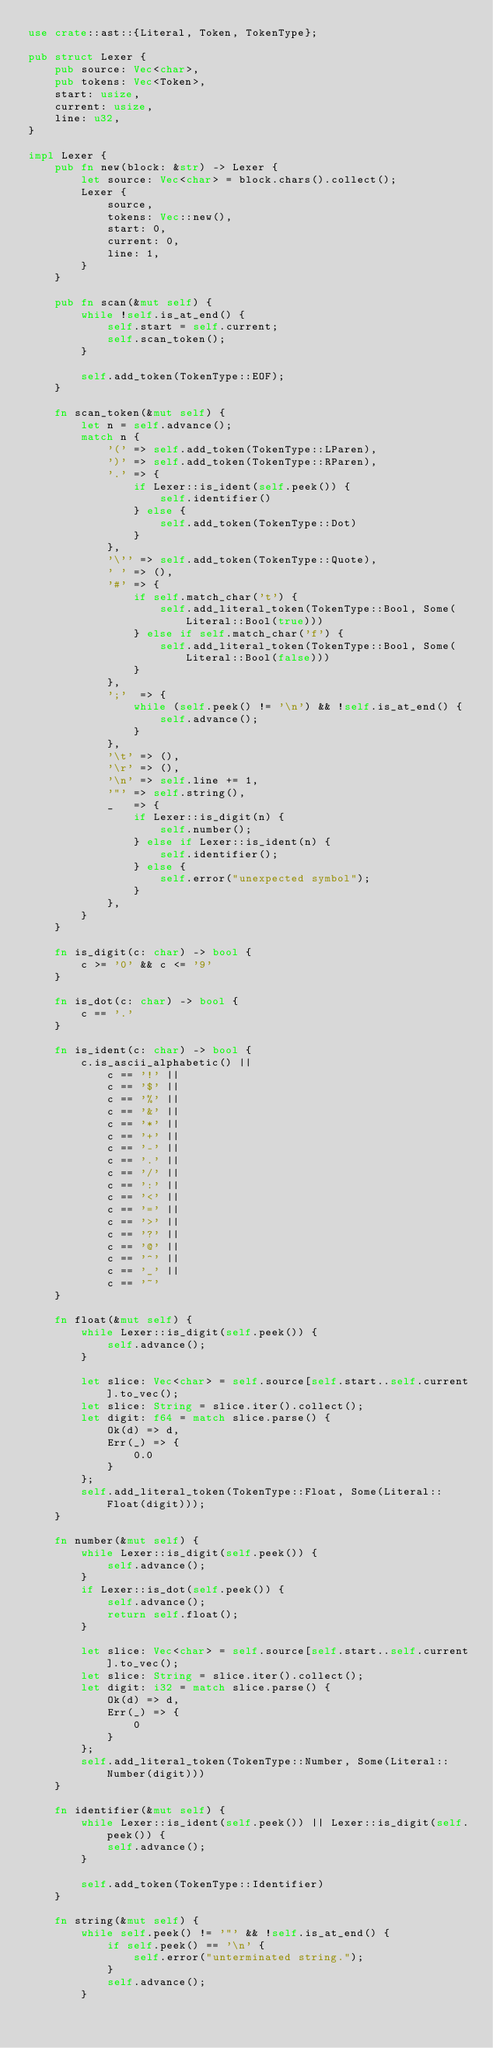Convert code to text. <code><loc_0><loc_0><loc_500><loc_500><_Rust_>use crate::ast::{Literal, Token, TokenType};

pub struct Lexer {
    pub source: Vec<char>,
    pub tokens: Vec<Token>,
    start: usize,
    current: usize,
    line: u32,
}

impl Lexer {
    pub fn new(block: &str) -> Lexer {
        let source: Vec<char> = block.chars().collect();
        Lexer {
            source,
            tokens: Vec::new(),
            start: 0,
            current: 0,
            line: 1,
        }
    }

    pub fn scan(&mut self) {
        while !self.is_at_end() {
            self.start = self.current;
            self.scan_token();
        }

        self.add_token(TokenType::EOF);
    }

    fn scan_token(&mut self) {
        let n = self.advance();
        match n {
            '(' => self.add_token(TokenType::LParen),
            ')' => self.add_token(TokenType::RParen),
            '.' => {
                if Lexer::is_ident(self.peek()) {
                    self.identifier()
                } else {
                    self.add_token(TokenType::Dot)
                }
            },
            '\'' => self.add_token(TokenType::Quote),
            ' ' => (),
            '#' => {
                if self.match_char('t') {
                    self.add_literal_token(TokenType::Bool, Some(Literal::Bool(true)))
                } else if self.match_char('f') {
                    self.add_literal_token(TokenType::Bool, Some(Literal::Bool(false)))
                }
            },
            ';'  => {
                while (self.peek() != '\n') && !self.is_at_end() {
                    self.advance();
                }
            },
            '\t' => (),
            '\r' => (),
            '\n' => self.line += 1,
            '"' => self.string(),
            _   => {
                if Lexer::is_digit(n) {
                    self.number();
                } else if Lexer::is_ident(n) {
                    self.identifier();
                } else {
                    self.error("unexpected symbol");
                }
            },
        }
    }

    fn is_digit(c: char) -> bool {
        c >= '0' && c <= '9'
    }

    fn is_dot(c: char) -> bool {
        c == '.'
    }

    fn is_ident(c: char) -> bool {
        c.is_ascii_alphabetic() ||
            c == '!' ||
            c == '$' ||
            c == '%' ||
            c == '&' ||
            c == '*' ||
            c == '+' ||
            c == '-' ||
            c == '.' ||
            c == '/' ||
            c == ':' ||
            c == '<' ||
            c == '=' ||
            c == '>' ||
            c == '?' ||
            c == '@' ||
            c == '^' ||
            c == '_' ||
            c == '~'
    }

    fn float(&mut self) {
        while Lexer::is_digit(self.peek()) {
            self.advance();
        }

        let slice: Vec<char> = self.source[self.start..self.current].to_vec();
        let slice: String = slice.iter().collect();
        let digit: f64 = match slice.parse() {
            Ok(d) => d,
            Err(_) => {
                0.0
            }
        };
        self.add_literal_token(TokenType::Float, Some(Literal::Float(digit)));
    }

    fn number(&mut self) {
        while Lexer::is_digit(self.peek()) {
            self.advance();
        }
        if Lexer::is_dot(self.peek()) {
            self.advance();
            return self.float();
        }

        let slice: Vec<char> = self.source[self.start..self.current].to_vec();
        let slice: String = slice.iter().collect();
        let digit: i32 = match slice.parse() {
            Ok(d) => d,
            Err(_) => {
                0
            }
        };
        self.add_literal_token(TokenType::Number, Some(Literal::Number(digit)))
    }

    fn identifier(&mut self) {
        while Lexer::is_ident(self.peek()) || Lexer::is_digit(self.peek()) {
            self.advance();
        }

        self.add_token(TokenType::Identifier)
    }

    fn string(&mut self) {
        while self.peek() != '"' && !self.is_at_end() {
            if self.peek() == '\n' {
                self.error("unterminated string.");
            }
            self.advance();
        }
</code> 